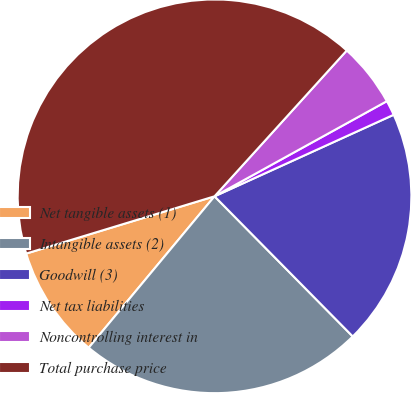<chart> <loc_0><loc_0><loc_500><loc_500><pie_chart><fcel>Net tangible assets (1)<fcel>Intangible assets (2)<fcel>Goodwill (3)<fcel>Net tax liabilities<fcel>Noncontrolling interest in<fcel>Total purchase price<nl><fcel>9.27%<fcel>23.43%<fcel>19.41%<fcel>1.23%<fcel>5.25%<fcel>41.43%<nl></chart> 